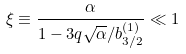Convert formula to latex. <formula><loc_0><loc_0><loc_500><loc_500>\xi \equiv \frac { \alpha } { 1 - 3 q \sqrt { \alpha } / b ^ { ( 1 ) } _ { 3 / 2 } } \ll 1</formula> 